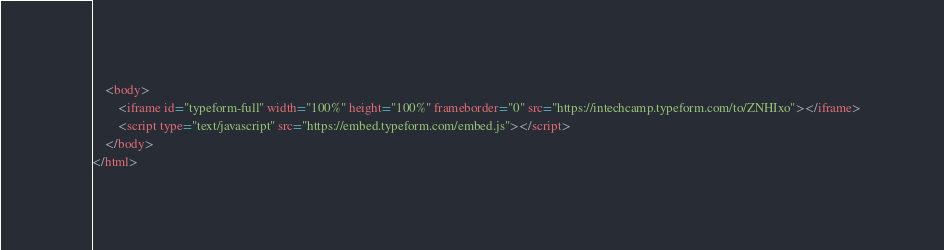Convert code to text. <code><loc_0><loc_0><loc_500><loc_500><_HTML_>	<body> 
		<iframe id="typeform-full" width="100%" height="100%" frameborder="0" src="https://intechcamp.typeform.com/to/ZNHIxo"></iframe> 
		<script type="text/javascript" src="https://embed.typeform.com/embed.js"></script> 
	</body> 
</html></code> 